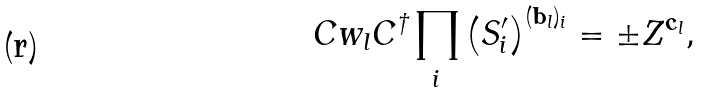Convert formula to latex. <formula><loc_0><loc_0><loc_500><loc_500>C w _ { l } C ^ { \dag } \prod _ { i } \left ( S _ { i } ^ { \prime } \right ) ^ { ( { { \mathbf b } _ { l } } ) _ { i } } = \pm Z ^ { { \mathbf c } _ { l } } ,</formula> 